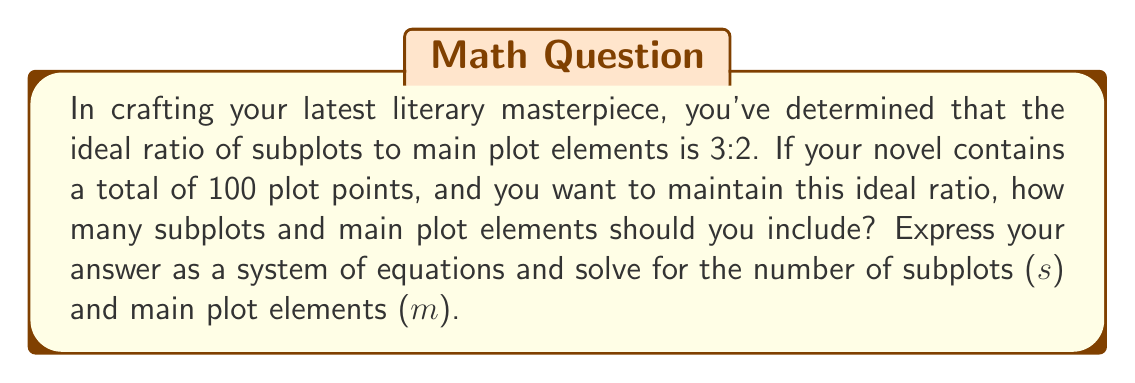Teach me how to tackle this problem. Let's approach this step-by-step:

1) First, let's define our variables:
   $s$ = number of subplots
   $m$ = number of main plot elements

2) We know the ratio of subplots to main plot elements is 3:2. This can be expressed as an equation:

   $$\frac{s}{m} = \frac{3}{2}$$

3) We can cross-multiply to get:

   $$2s = 3m$$

4) We also know that the total number of plot points is 100. This gives us our second equation:

   $$s + m = 100$$

5) Now we have a system of two equations with two unknowns:

   $$\begin{cases}
   2s = 3m \\
   s + m = 100
   \end{cases}$$

6) We can solve this system by substitution. From the first equation, we can express $s$ in terms of $m$:

   $$s = \frac{3m}{2}$$

7) Substitute this into the second equation:

   $$\frac{3m}{2} + m = 100$$

8) Simplify:

   $$\frac{3m + 2m}{2} = 100$$
   $$\frac{5m}{2} = 100$$

9) Multiply both sides by 2:

   $$5m = 200$$

10) Solve for $m$:

    $$m = 40$$

11) Now that we know $m$, we can find $s$ using either of our original equations. Let's use the second one:

    $$s + 40 = 100$$
    $$s = 60$$

12) We can verify this satisfies our ratio:

    $$\frac{s}{m} = \frac{60}{40} = \frac{3}{2}$$

Therefore, to maintain the ideal ratio, the novel should have 60 subplots and 40 main plot elements.
Answer: $$\begin{cases}
s = 60 \\
m = 40
\end{cases}$$ 